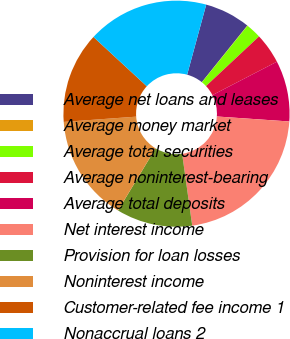Convert chart. <chart><loc_0><loc_0><loc_500><loc_500><pie_chart><fcel>Average net loans and leases<fcel>Average money market<fcel>Average total securities<fcel>Average noninterest-bearing<fcel>Average total deposits<fcel>Net interest income<fcel>Provision for loan losses<fcel>Noninterest income<fcel>Customer-related fee income 1<fcel>Nonaccrual loans 2<nl><fcel>6.54%<fcel>0.04%<fcel>2.21%<fcel>4.37%<fcel>8.7%<fcel>21.69%<fcel>10.87%<fcel>15.19%<fcel>13.03%<fcel>17.36%<nl></chart> 